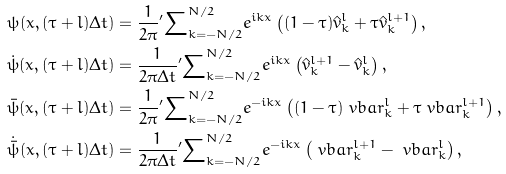<formula> <loc_0><loc_0><loc_500><loc_500>\psi ( x , ( \tau + l ) \Delta t ) & = \frac { 1 } { 2 \pi } { ^ { \prime } } { \sum } _ { k = - N / 2 } ^ { N / 2 } e ^ { i k x } \left ( ( 1 - \tau ) \hat { v } _ { k } ^ { l } + \tau \hat { v } _ { k } ^ { l + 1 } \right ) , \\ \dot { \psi } ( x , ( \tau + l ) \Delta t ) & = \frac { 1 } { 2 \pi \Delta t } { ^ { \prime } } { \sum } _ { k = - N / 2 } ^ { N / 2 } e ^ { i k x } \left ( \hat { v } _ { k } ^ { l + 1 } - \hat { v } _ { k } ^ { l } \right ) , \\ \bar { \psi } ( x , ( \tau + l ) \Delta t ) & = \frac { 1 } { 2 \pi } { ^ { \prime } } { \sum } _ { k = - N / 2 } ^ { N / 2 } e ^ { - i k x } \left ( ( 1 - \tau ) \ v b a r _ { k } ^ { l } + \tau \ v b a r _ { k } ^ { l + 1 } \right ) , \\ \dot { \bar { \psi } } ( x , ( \tau + l ) \Delta t ) & = \frac { 1 } { 2 \pi \Delta t } { ^ { \prime } } { \sum } _ { k = - N / 2 } ^ { N / 2 } e ^ { - i k x } \left ( \ v b a r _ { k } ^ { l + 1 } - \ v b a r _ { k } ^ { l } \right ) ,</formula> 